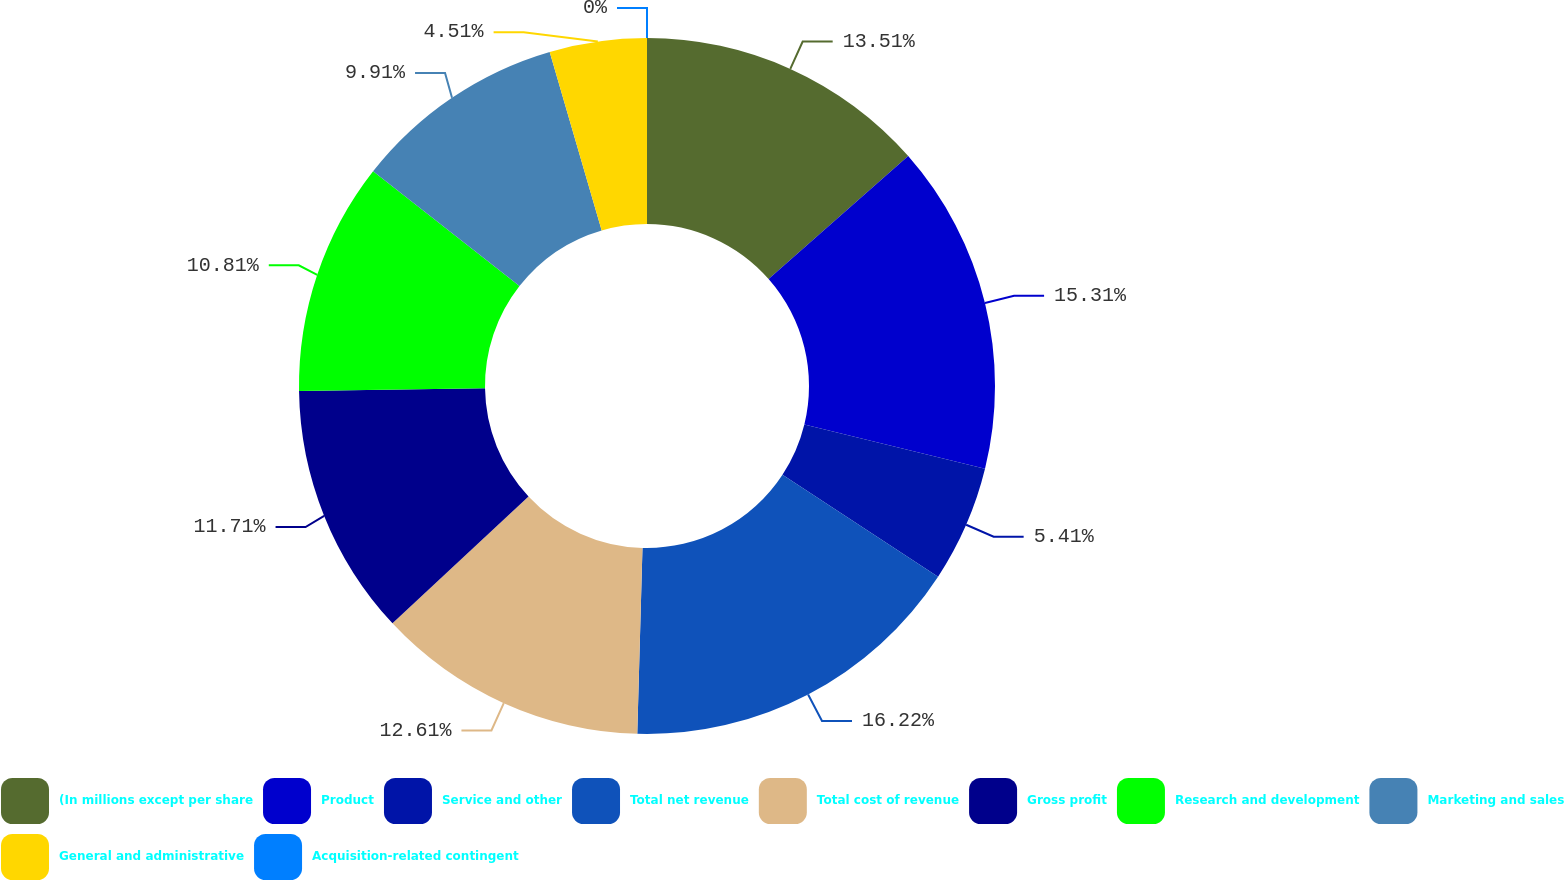Convert chart. <chart><loc_0><loc_0><loc_500><loc_500><pie_chart><fcel>(In millions except per share<fcel>Product<fcel>Service and other<fcel>Total net revenue<fcel>Total cost of revenue<fcel>Gross profit<fcel>Research and development<fcel>Marketing and sales<fcel>General and administrative<fcel>Acquisition-related contingent<nl><fcel>13.51%<fcel>15.31%<fcel>5.41%<fcel>16.21%<fcel>12.61%<fcel>11.71%<fcel>10.81%<fcel>9.91%<fcel>4.51%<fcel>0.0%<nl></chart> 